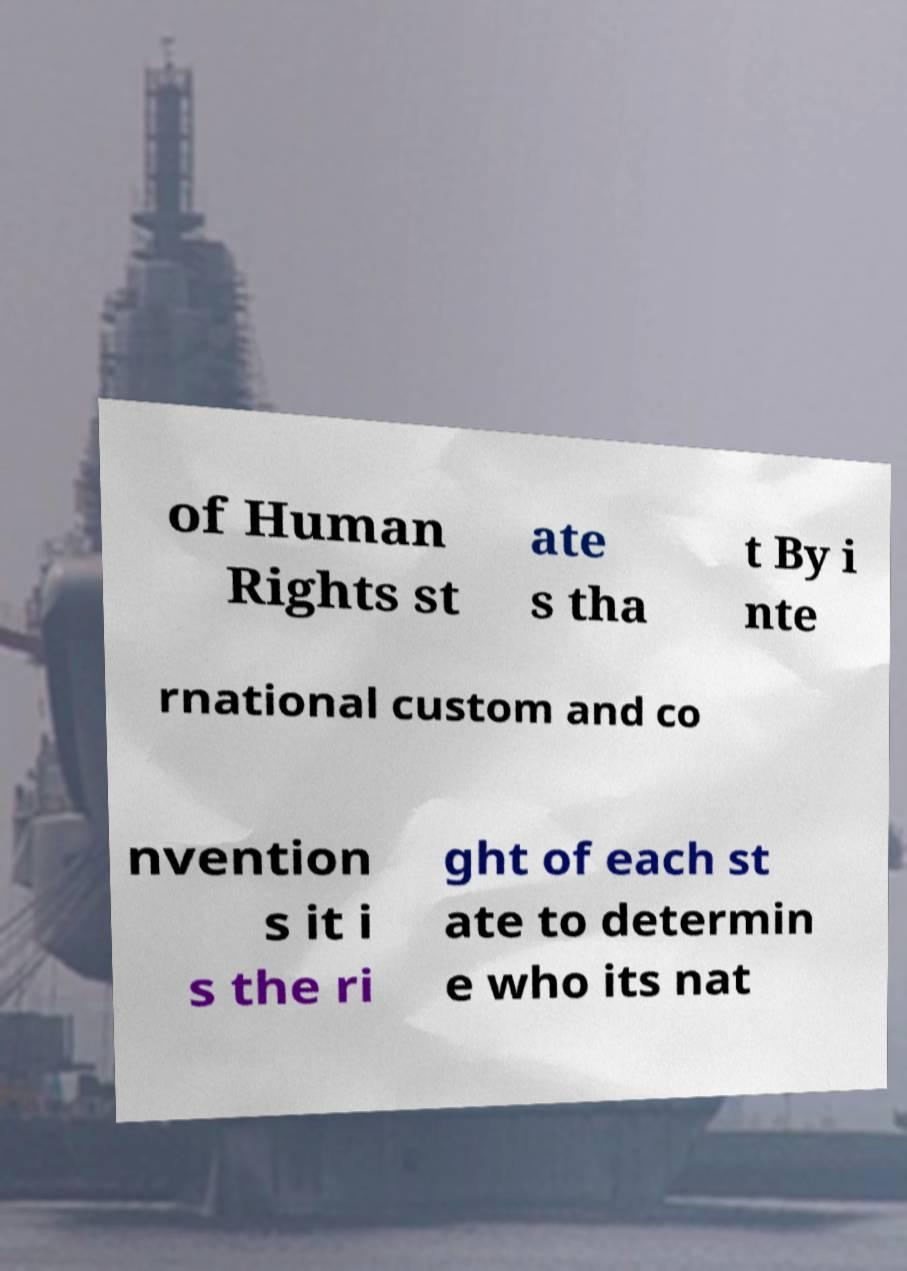For documentation purposes, I need the text within this image transcribed. Could you provide that? of Human Rights st ate s tha t By i nte rnational custom and co nvention s it i s the ri ght of each st ate to determin e who its nat 